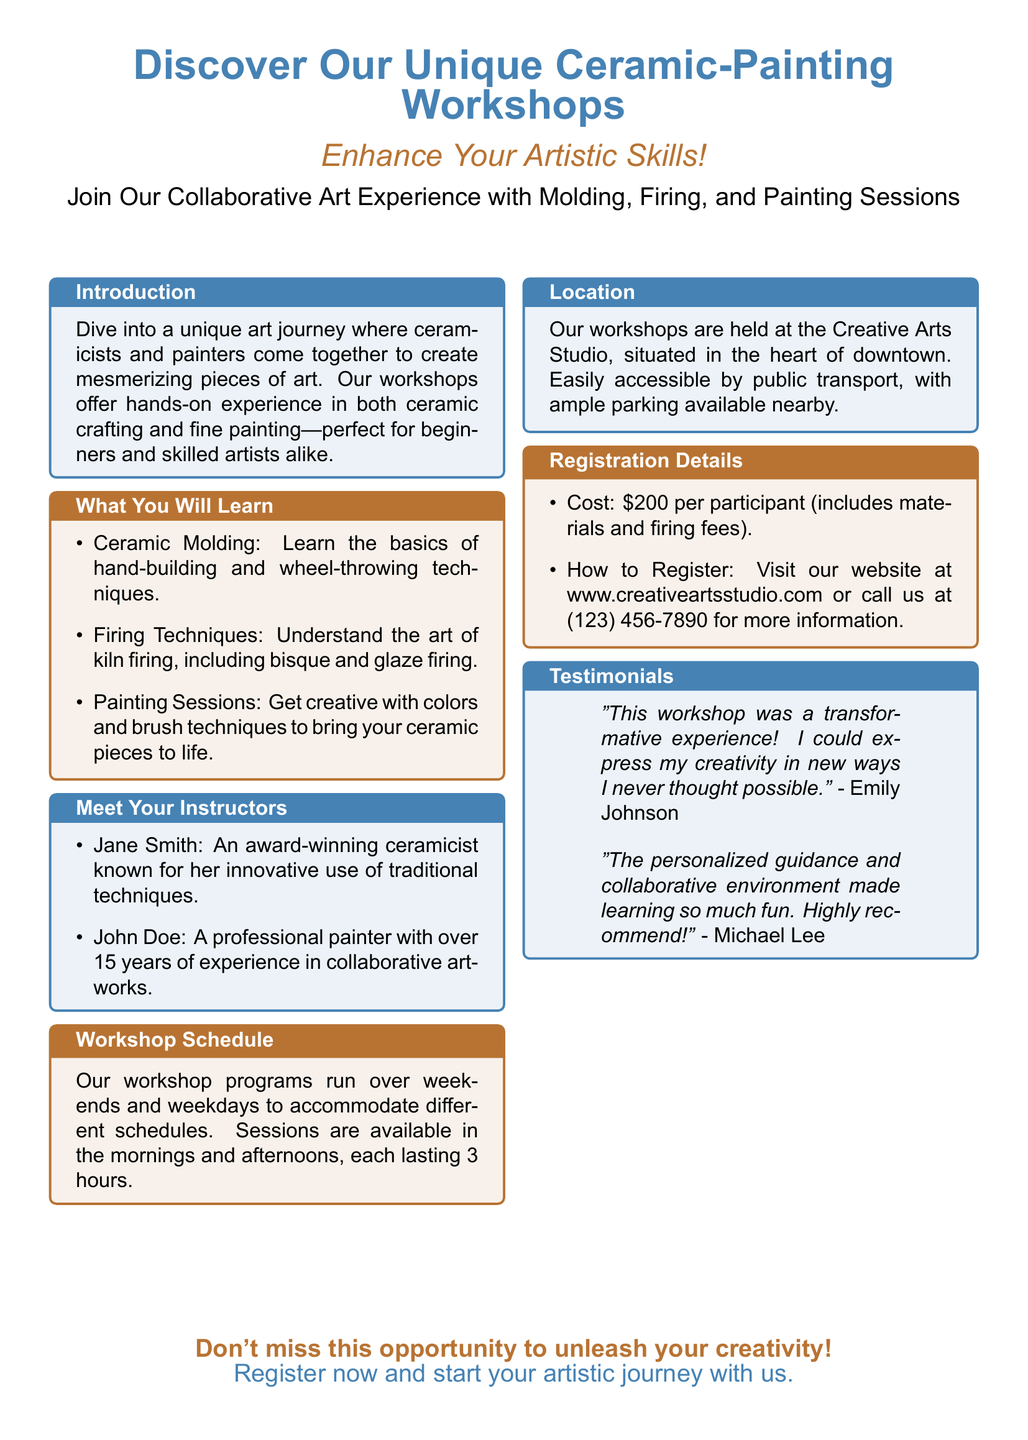What are the workshop hours? The workshop sessions last for 3 hours and are available in the mornings and afternoons.
Answer: 3 hours Who is the ceramicist instructor? The document specifies Jane Smith as an award-winning ceramicist.
Answer: Jane Smith What is the cost to participate in the workshop? The registration details mention that the cost is $200 per participant.
Answer: $200 Where are the workshops held? The location section mentions the workshops are held at the Creative Arts Studio in downtown.
Answer: Creative Arts Studio What techniques will be taught? The workshop will cover ceramic molding, firing techniques, and painting sessions.
Answer: Ceramic molding, firing techniques, painting sessions Name one testimonial provided. The testimonials section quotes Emily Johnson and Michael Lee providing positive feedback.
Answer: "This workshop was a transformative experience!" What is required for registration? The registration details state that participants can visit the website or call for more information.
Answer: Visit our website or call us Who joins the ceramicist in teaching? The document indicates that John Doe also instructs in the workshop alongside Jane Smith.
Answer: John Doe What type of art experience does the workshop offer? The introduction mentions a collaborative art experience involving both ceramic crafting and painting.
Answer: Collaborative art experience 